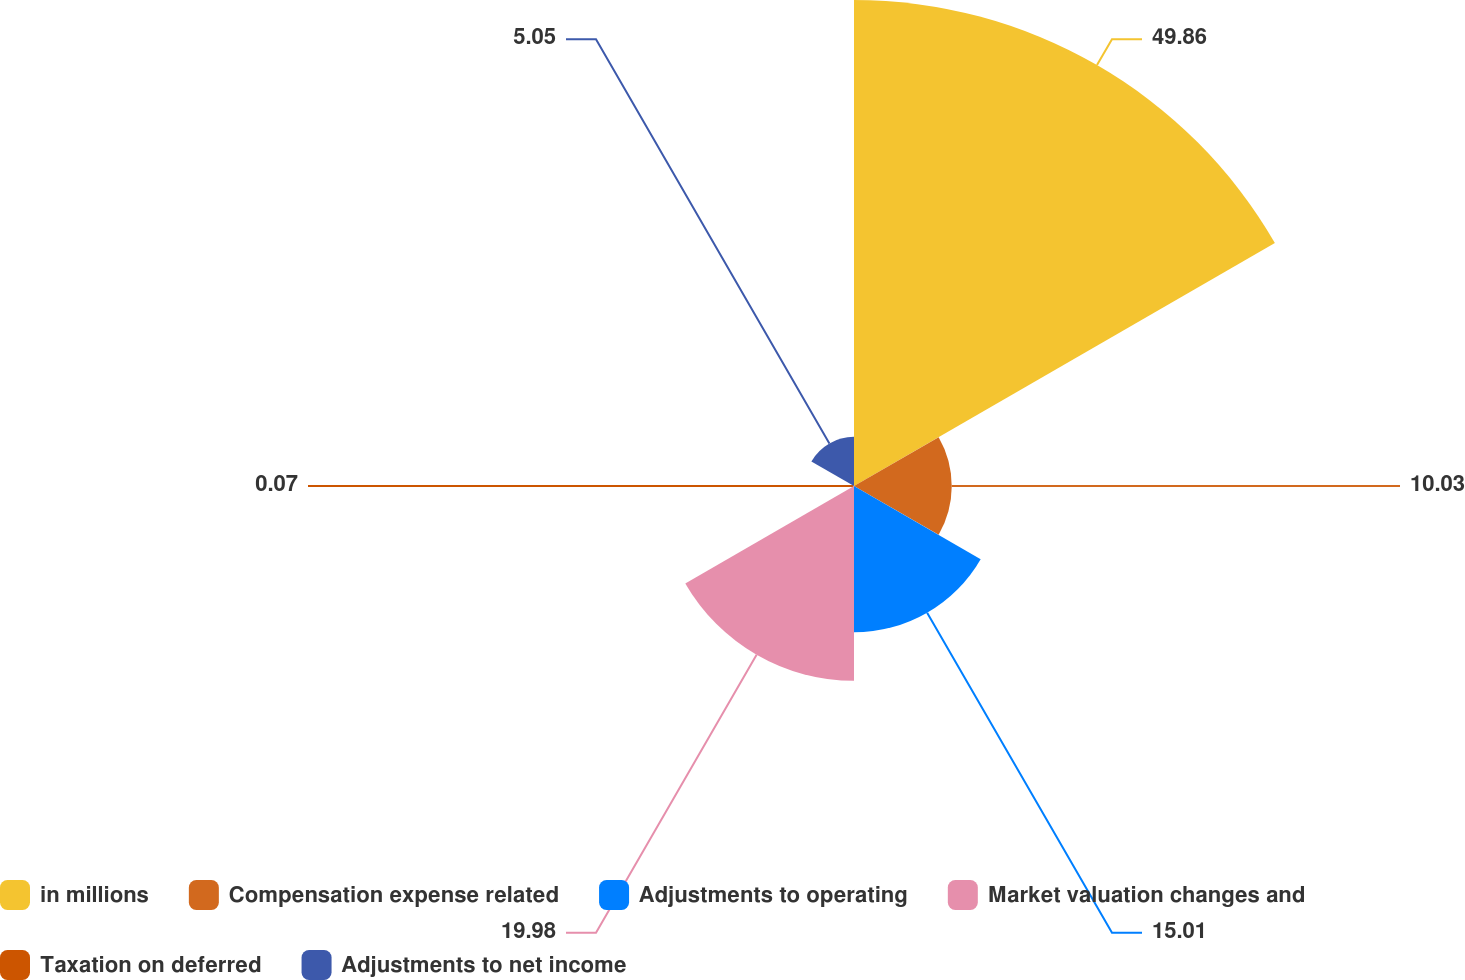Convert chart. <chart><loc_0><loc_0><loc_500><loc_500><pie_chart><fcel>in millions<fcel>Compensation expense related<fcel>Adjustments to operating<fcel>Market valuation changes and<fcel>Taxation on deferred<fcel>Adjustments to net income<nl><fcel>49.87%<fcel>10.03%<fcel>15.01%<fcel>19.99%<fcel>0.07%<fcel>5.05%<nl></chart> 